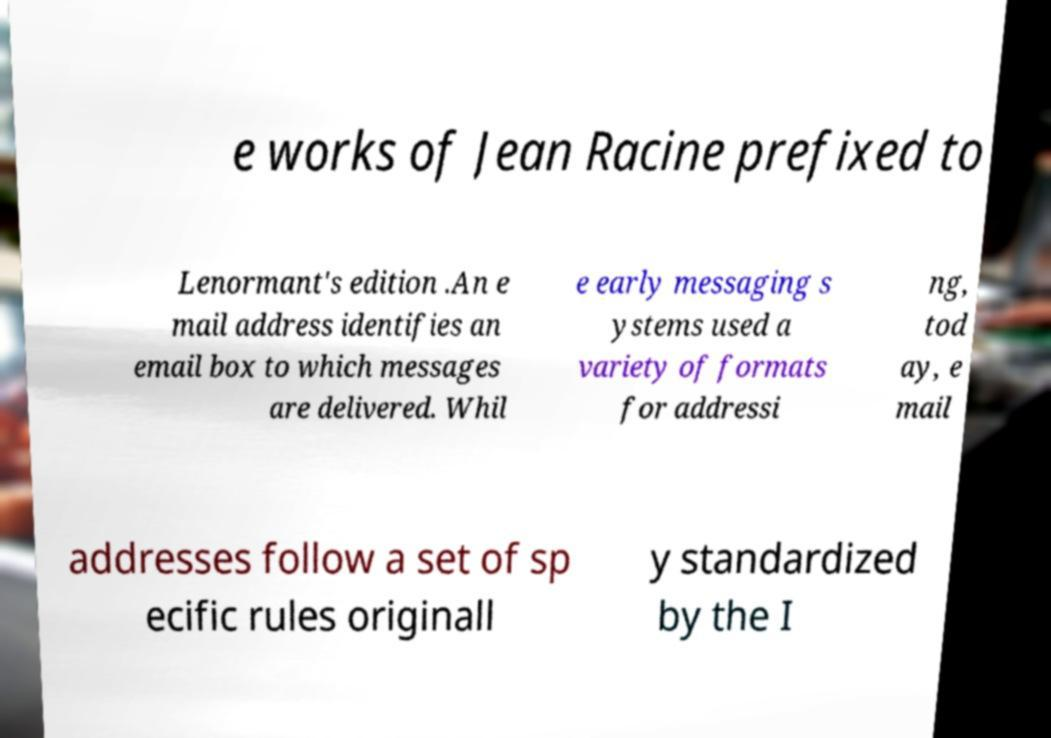There's text embedded in this image that I need extracted. Can you transcribe it verbatim? e works of Jean Racine prefixed to Lenormant's edition .An e mail address identifies an email box to which messages are delivered. Whil e early messaging s ystems used a variety of formats for addressi ng, tod ay, e mail addresses follow a set of sp ecific rules originall y standardized by the I 